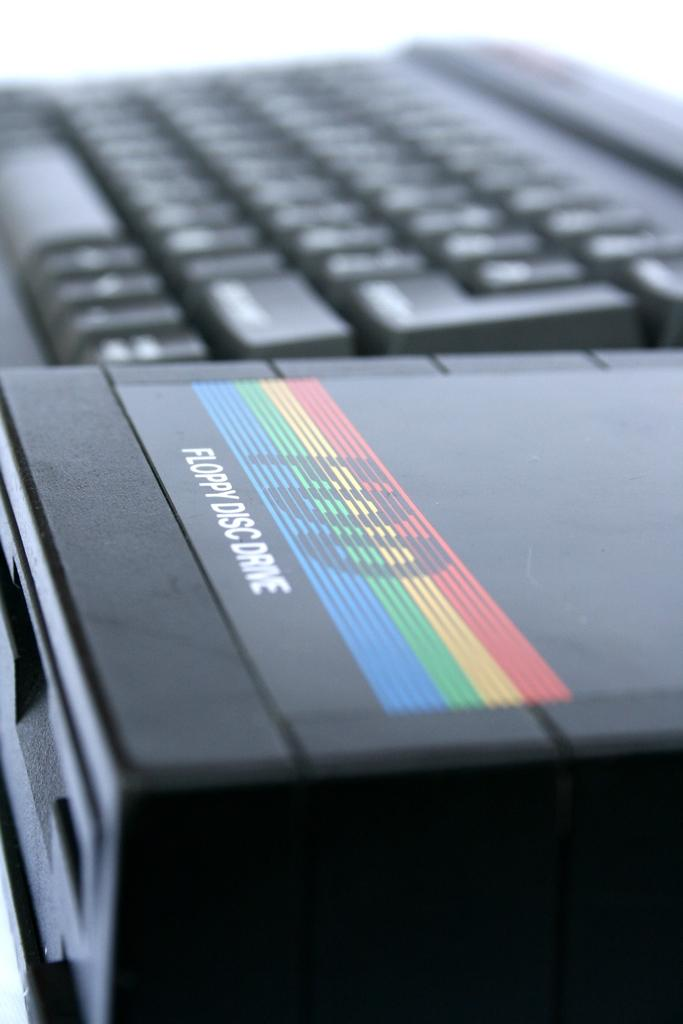<image>
Create a compact narrative representing the image presented. A floppy disc drive sits next to a computer keyboard. 